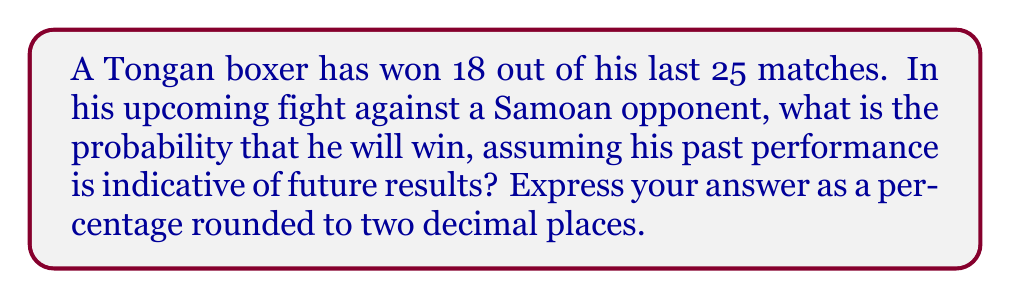Provide a solution to this math problem. To solve this problem, we'll use the concept of relative frequency as an estimate of probability. Here's the step-by-step solution:

1. Identify the given information:
   - Total matches fought: 25
   - Matches won: 18

2. Calculate the probability of winning:
   $$ P(\text{win}) = \frac{\text{Number of wins}}{\text{Total number of matches}} $$
   
   $$ P(\text{win}) = \frac{18}{25} $$

3. Convert the fraction to a decimal:
   $$ \frac{18}{25} = 0.72 $$

4. Convert the decimal to a percentage:
   $$ 0.72 \times 100\% = 72\% $$

5. Round to two decimal places:
   $$ 72.00\% $$

Therefore, based on the Tongan boxer's past performance, there is a 72.00% probability that he will win the upcoming match against his Samoan opponent.
Answer: 72.00% 